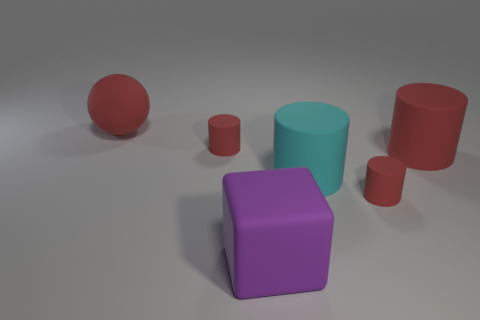What color is the matte cylinder that is both behind the large cyan rubber object and right of the cyan object?
Give a very brief answer. Red. What is the size of the red rubber thing that is in front of the large red matte thing that is in front of the big ball?
Provide a succinct answer. Small. Are there any other things that have the same color as the large sphere?
Your answer should be compact. Yes. There is a big thing that is both on the left side of the cyan cylinder and in front of the big red cylinder; what is it made of?
Your response must be concise. Rubber. There is a cyan rubber object; does it have the same shape as the small red rubber object that is behind the big cyan thing?
Provide a short and direct response. Yes. What material is the small thing on the left side of the red cylinder in front of the big red rubber cylinder right of the big cyan rubber cylinder?
Offer a very short reply. Rubber. There is a large red rubber thing on the right side of the large red object on the left side of the purple matte object; what number of big spheres are in front of it?
Make the answer very short. 0. Are there any large red rubber objects that have the same shape as the cyan object?
Offer a very short reply. Yes. What is the color of the sphere that is the same size as the purple object?
Your answer should be compact. Red. What number of things are either large things that are right of the large cube or large things that are behind the purple cube?
Your answer should be very brief. 3. 